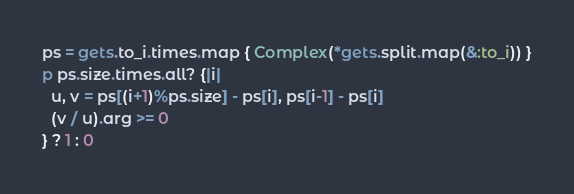<code> <loc_0><loc_0><loc_500><loc_500><_Ruby_>ps = gets.to_i.times.map { Complex(*gets.split.map(&:to_i)) }
p ps.size.times.all? {|i|
  u, v = ps[(i+1)%ps.size] - ps[i], ps[i-1] - ps[i]
  (v / u).arg >= 0
} ? 1 : 0</code> 